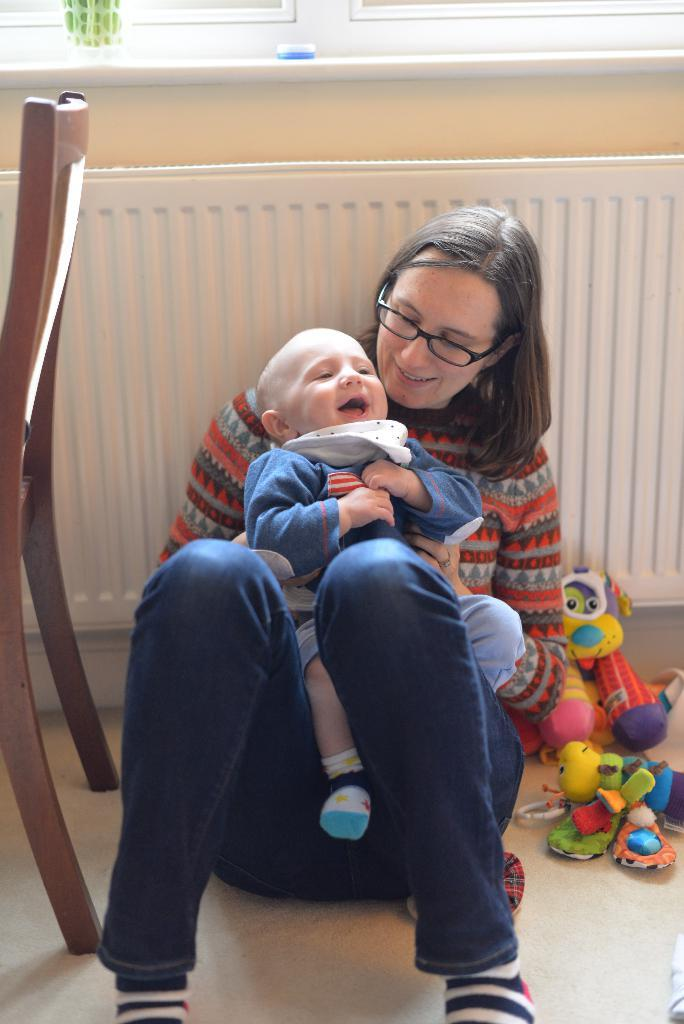Who is present in the image? There is a woman in the image. What is the woman doing in the image? The woman is sitting on the floor. Is there anyone else with the woman in the image? Yes, there is a baby with the woman. What else can be seen in the image? There is a chair and toys on the floor. What type of cake is being served to the woman in the image? There is no cake present in the image. How many stars can be seen in the image? There are no stars visible in the image. 